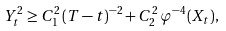Convert formula to latex. <formula><loc_0><loc_0><loc_500><loc_500>Y _ { t } ^ { 2 } \geq C _ { 1 } ^ { 2 } \, ( T - t ) ^ { - 2 } + C _ { 2 } ^ { 2 } \, \varphi ^ { - 4 } ( X _ { t } ) ,</formula> 